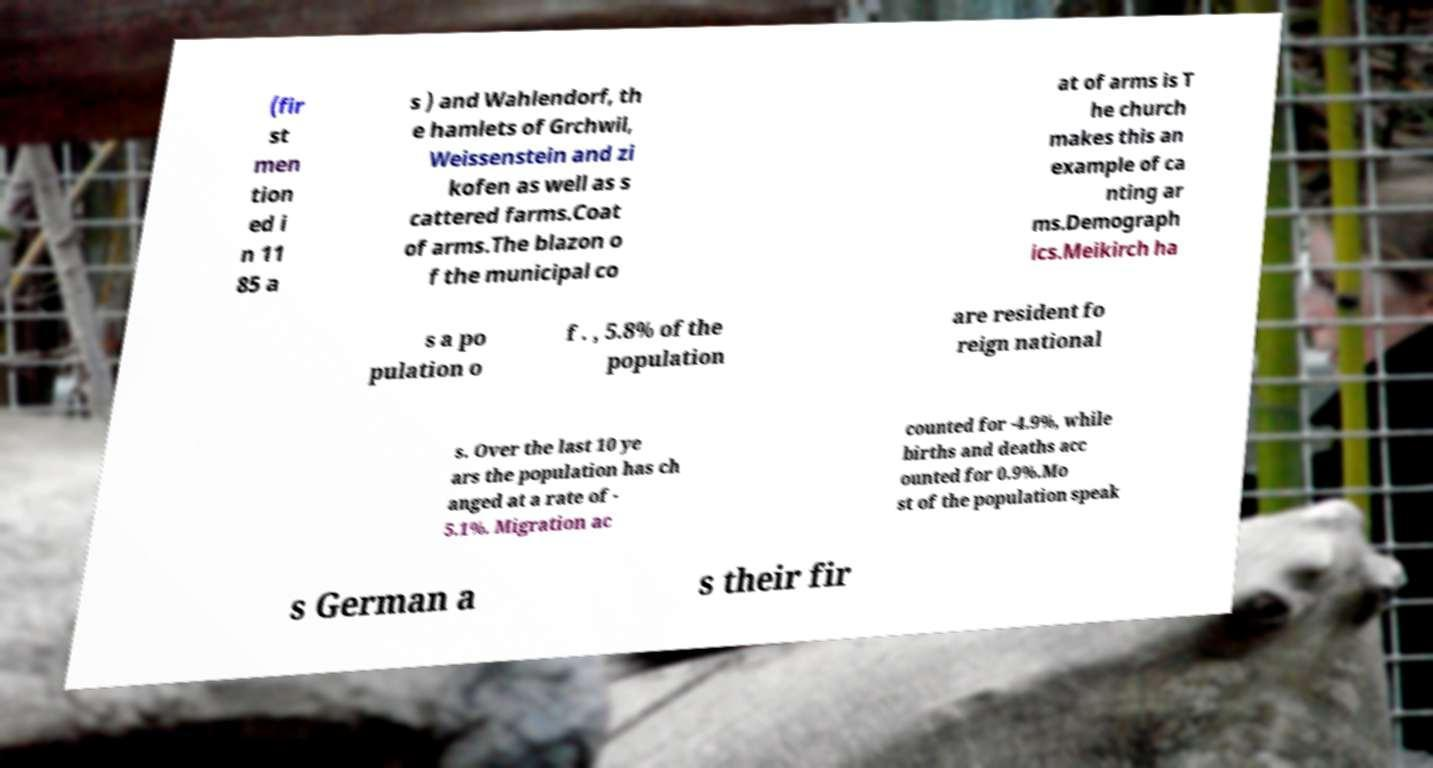Please identify and transcribe the text found in this image. (fir st men tion ed i n 11 85 a s ) and Wahlendorf, th e hamlets of Grchwil, Weissenstein and zi kofen as well as s cattered farms.Coat of arms.The blazon o f the municipal co at of arms is T he church makes this an example of ca nting ar ms.Demograph ics.Meikirch ha s a po pulation o f . , 5.8% of the population are resident fo reign national s. Over the last 10 ye ars the population has ch anged at a rate of - 5.1%. Migration ac counted for -4.9%, while births and deaths acc ounted for 0.9%.Mo st of the population speak s German a s their fir 